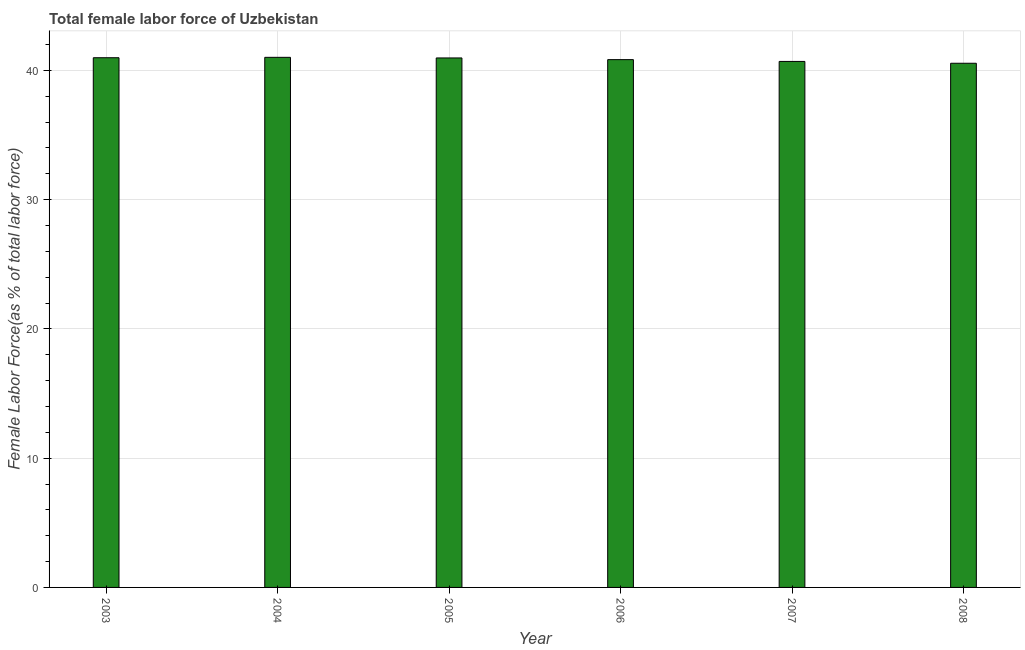Does the graph contain any zero values?
Provide a short and direct response. No. What is the title of the graph?
Provide a succinct answer. Total female labor force of Uzbekistan. What is the label or title of the Y-axis?
Make the answer very short. Female Labor Force(as % of total labor force). What is the total female labor force in 2007?
Your answer should be very brief. 40.7. Across all years, what is the maximum total female labor force?
Give a very brief answer. 41.01. Across all years, what is the minimum total female labor force?
Provide a short and direct response. 40.56. What is the sum of the total female labor force?
Your response must be concise. 245.05. What is the difference between the total female labor force in 2007 and 2008?
Your answer should be very brief. 0.14. What is the average total female labor force per year?
Your answer should be very brief. 40.84. What is the median total female labor force?
Your answer should be compact. 40.9. In how many years, is the total female labor force greater than 26 %?
Provide a succinct answer. 6. What is the ratio of the total female labor force in 2004 to that in 2008?
Your answer should be very brief. 1.01. Is the difference between the total female labor force in 2004 and 2005 greater than the difference between any two years?
Keep it short and to the point. No. What is the difference between the highest and the second highest total female labor force?
Give a very brief answer. 0.03. What is the difference between the highest and the lowest total female labor force?
Your answer should be very brief. 0.46. In how many years, is the total female labor force greater than the average total female labor force taken over all years?
Your answer should be very brief. 3. How many bars are there?
Keep it short and to the point. 6. Are all the bars in the graph horizontal?
Offer a terse response. No. What is the difference between two consecutive major ticks on the Y-axis?
Offer a very short reply. 10. Are the values on the major ticks of Y-axis written in scientific E-notation?
Give a very brief answer. No. What is the Female Labor Force(as % of total labor force) in 2003?
Your answer should be compact. 40.98. What is the Female Labor Force(as % of total labor force) of 2004?
Offer a terse response. 41.01. What is the Female Labor Force(as % of total labor force) in 2005?
Provide a succinct answer. 40.97. What is the Female Labor Force(as % of total labor force) of 2006?
Your response must be concise. 40.84. What is the Female Labor Force(as % of total labor force) in 2007?
Ensure brevity in your answer.  40.7. What is the Female Labor Force(as % of total labor force) in 2008?
Your answer should be compact. 40.56. What is the difference between the Female Labor Force(as % of total labor force) in 2003 and 2004?
Keep it short and to the point. -0.03. What is the difference between the Female Labor Force(as % of total labor force) in 2003 and 2005?
Ensure brevity in your answer.  0.02. What is the difference between the Female Labor Force(as % of total labor force) in 2003 and 2006?
Offer a terse response. 0.15. What is the difference between the Female Labor Force(as % of total labor force) in 2003 and 2007?
Ensure brevity in your answer.  0.29. What is the difference between the Female Labor Force(as % of total labor force) in 2003 and 2008?
Provide a succinct answer. 0.43. What is the difference between the Female Labor Force(as % of total labor force) in 2004 and 2005?
Ensure brevity in your answer.  0.05. What is the difference between the Female Labor Force(as % of total labor force) in 2004 and 2006?
Your answer should be compact. 0.18. What is the difference between the Female Labor Force(as % of total labor force) in 2004 and 2007?
Offer a very short reply. 0.32. What is the difference between the Female Labor Force(as % of total labor force) in 2004 and 2008?
Your answer should be very brief. 0.46. What is the difference between the Female Labor Force(as % of total labor force) in 2005 and 2006?
Your answer should be compact. 0.13. What is the difference between the Female Labor Force(as % of total labor force) in 2005 and 2007?
Give a very brief answer. 0.27. What is the difference between the Female Labor Force(as % of total labor force) in 2005 and 2008?
Your answer should be very brief. 0.41. What is the difference between the Female Labor Force(as % of total labor force) in 2006 and 2007?
Offer a very short reply. 0.14. What is the difference between the Female Labor Force(as % of total labor force) in 2006 and 2008?
Offer a terse response. 0.28. What is the difference between the Female Labor Force(as % of total labor force) in 2007 and 2008?
Ensure brevity in your answer.  0.14. What is the ratio of the Female Labor Force(as % of total labor force) in 2003 to that in 2004?
Your answer should be very brief. 1. What is the ratio of the Female Labor Force(as % of total labor force) in 2003 to that in 2006?
Your response must be concise. 1. What is the ratio of the Female Labor Force(as % of total labor force) in 2003 to that in 2007?
Keep it short and to the point. 1.01. What is the ratio of the Female Labor Force(as % of total labor force) in 2004 to that in 2005?
Your answer should be compact. 1. What is the ratio of the Female Labor Force(as % of total labor force) in 2004 to that in 2008?
Keep it short and to the point. 1.01. What is the ratio of the Female Labor Force(as % of total labor force) in 2005 to that in 2006?
Your answer should be very brief. 1. What is the ratio of the Female Labor Force(as % of total labor force) in 2005 to that in 2007?
Provide a succinct answer. 1.01. What is the ratio of the Female Labor Force(as % of total labor force) in 2005 to that in 2008?
Keep it short and to the point. 1.01. What is the ratio of the Female Labor Force(as % of total labor force) in 2006 to that in 2007?
Provide a succinct answer. 1. What is the ratio of the Female Labor Force(as % of total labor force) in 2007 to that in 2008?
Offer a very short reply. 1. 